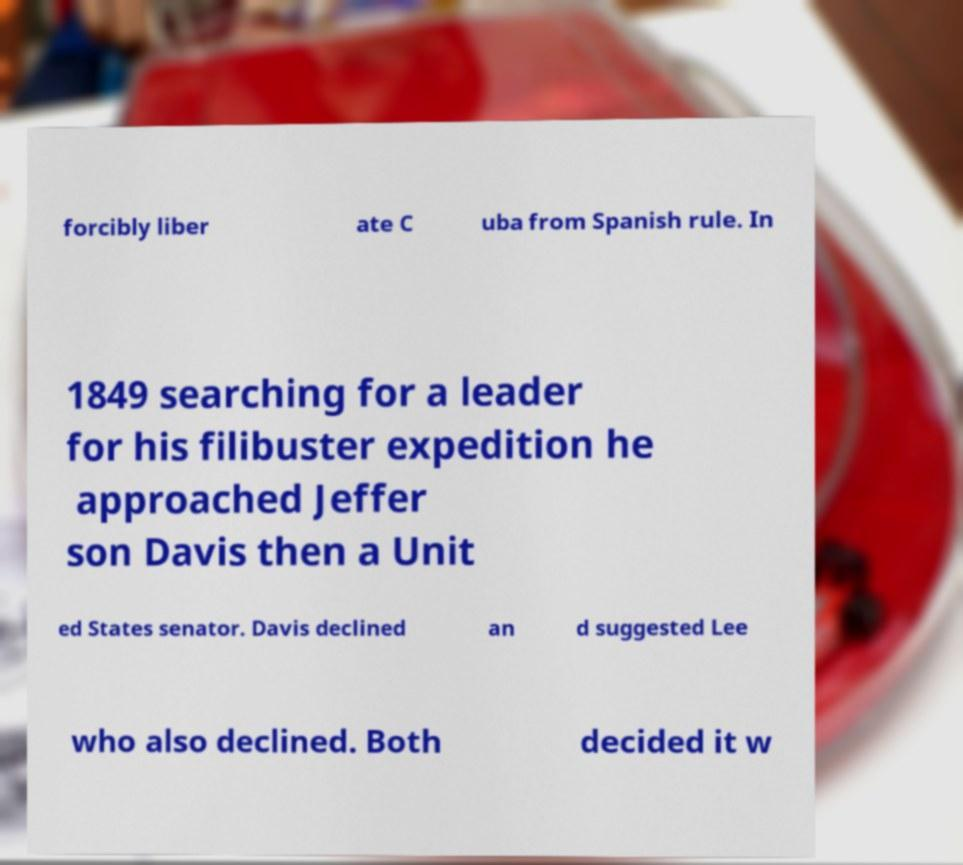Could you extract and type out the text from this image? forcibly liber ate C uba from Spanish rule. In 1849 searching for a leader for his filibuster expedition he approached Jeffer son Davis then a Unit ed States senator. Davis declined an d suggested Lee who also declined. Both decided it w 